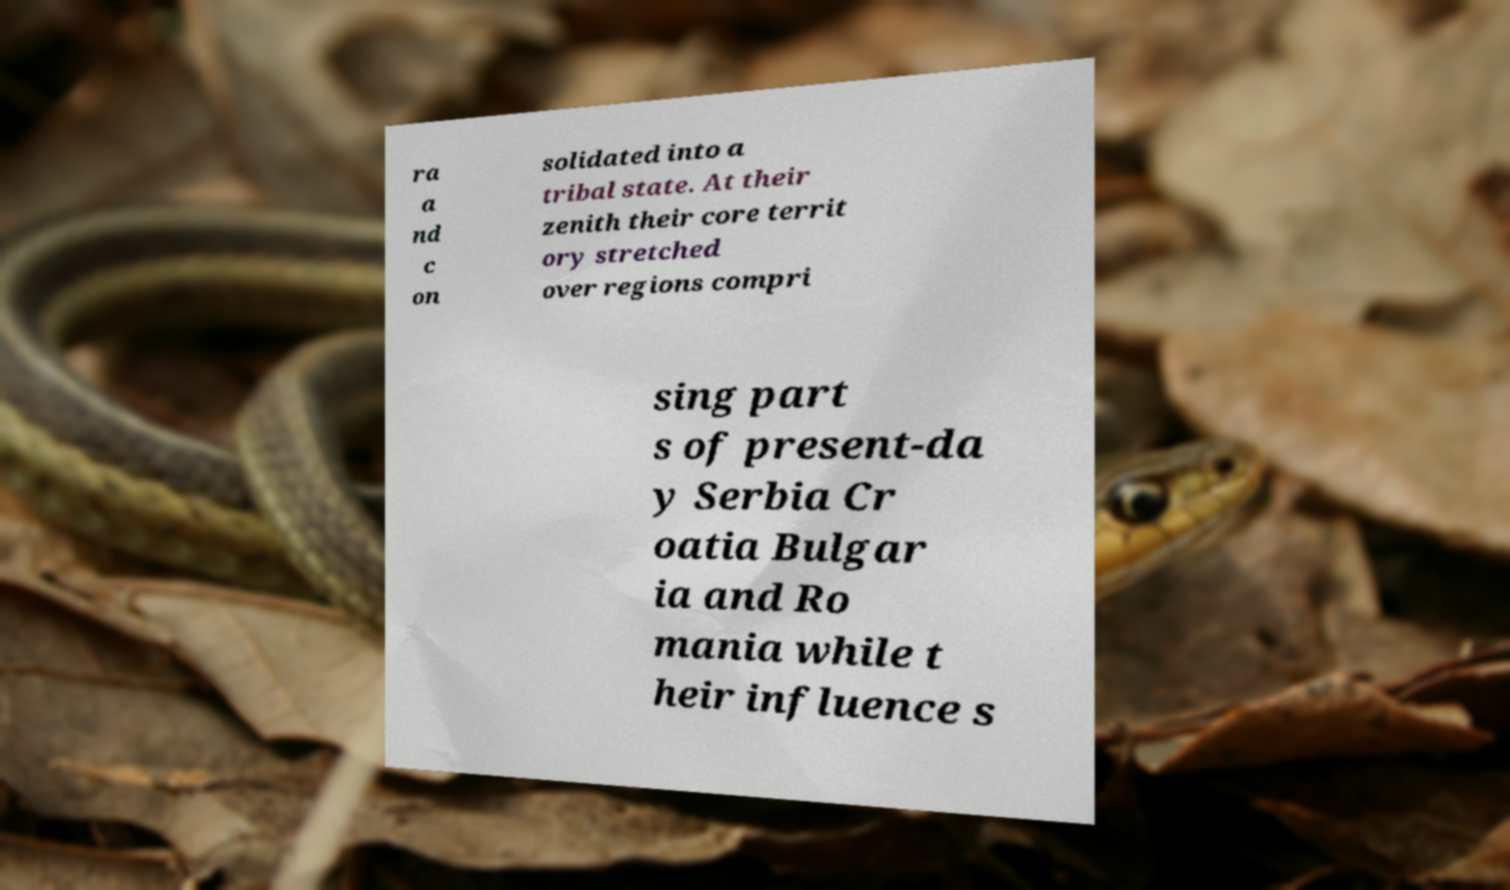Can you accurately transcribe the text from the provided image for me? ra a nd c on solidated into a tribal state. At their zenith their core territ ory stretched over regions compri sing part s of present-da y Serbia Cr oatia Bulgar ia and Ro mania while t heir influence s 